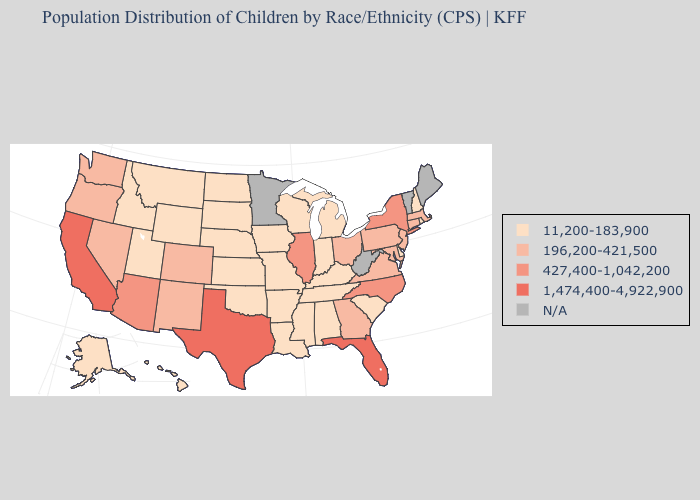Among the states that border New Mexico , which have the highest value?
Keep it brief. Texas. What is the lowest value in the USA?
Be succinct. 11,200-183,900. Name the states that have a value in the range 11,200-183,900?
Write a very short answer. Alabama, Alaska, Arkansas, Delaware, Hawaii, Idaho, Indiana, Iowa, Kansas, Kentucky, Louisiana, Michigan, Mississippi, Missouri, Montana, Nebraska, New Hampshire, North Dakota, Oklahoma, Rhode Island, South Carolina, South Dakota, Tennessee, Utah, Wisconsin, Wyoming. Among the states that border Pennsylvania , does New Jersey have the lowest value?
Short answer required. No. Name the states that have a value in the range 1,474,400-4,922,900?
Give a very brief answer. California, Florida, Texas. What is the value of Idaho?
Answer briefly. 11,200-183,900. What is the highest value in states that border Wyoming?
Quick response, please. 196,200-421,500. What is the value of West Virginia?
Write a very short answer. N/A. Among the states that border Maryland , does Pennsylvania have the lowest value?
Quick response, please. No. What is the lowest value in states that border Georgia?
Answer briefly. 11,200-183,900. What is the value of Tennessee?
Short answer required. 11,200-183,900. Among the states that border Rhode Island , which have the lowest value?
Short answer required. Connecticut, Massachusetts. Which states have the lowest value in the South?
Write a very short answer. Alabama, Arkansas, Delaware, Kentucky, Louisiana, Mississippi, Oklahoma, South Carolina, Tennessee. What is the value of Kansas?
Concise answer only. 11,200-183,900. What is the value of Georgia?
Keep it brief. 196,200-421,500. 